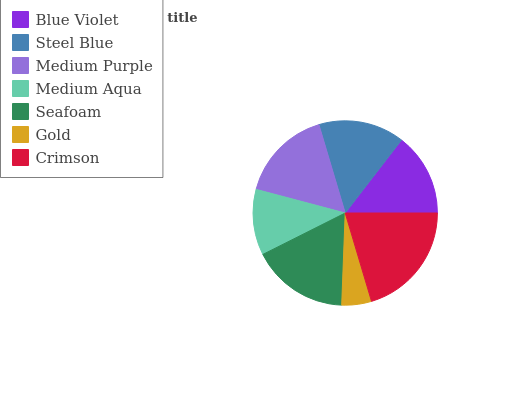Is Gold the minimum?
Answer yes or no. Yes. Is Crimson the maximum?
Answer yes or no. Yes. Is Steel Blue the minimum?
Answer yes or no. No. Is Steel Blue the maximum?
Answer yes or no. No. Is Steel Blue greater than Blue Violet?
Answer yes or no. Yes. Is Blue Violet less than Steel Blue?
Answer yes or no. Yes. Is Blue Violet greater than Steel Blue?
Answer yes or no. No. Is Steel Blue less than Blue Violet?
Answer yes or no. No. Is Steel Blue the high median?
Answer yes or no. Yes. Is Steel Blue the low median?
Answer yes or no. Yes. Is Seafoam the high median?
Answer yes or no. No. Is Medium Purple the low median?
Answer yes or no. No. 